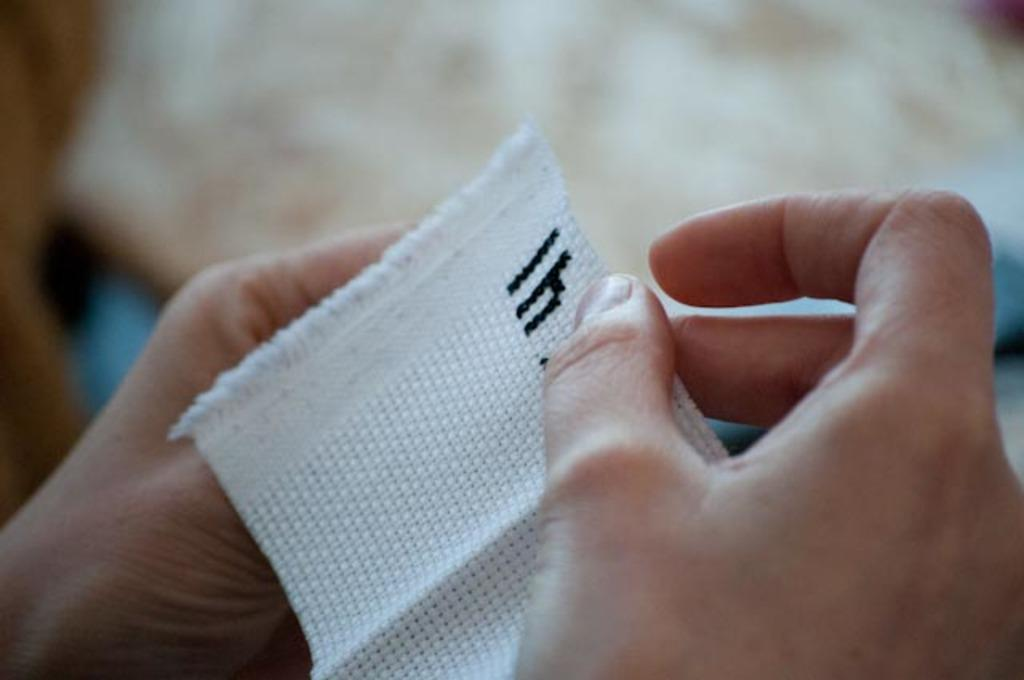What is the main subject of the image? There is a person in the image. What is the person holding in the image? The person is holding a white cloth. Can you describe the background of the image? The background of the image is blurred. How many geese are visible in the image? There are no geese present in the image. What type of potato is being used by the person in the image? There is no potato present in the image. 